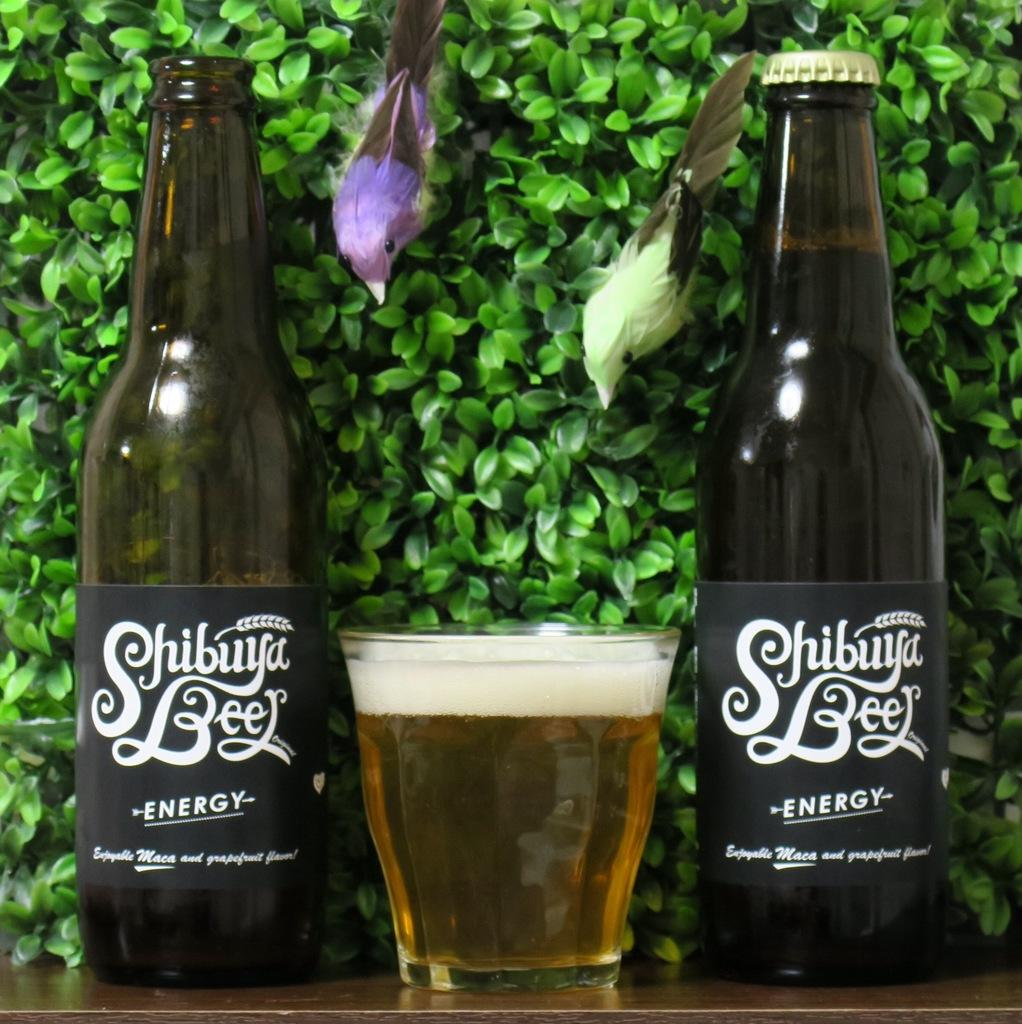<image>
Create a compact narrative representing the image presented. Two bottles of Shibuya beer sit on either side of a glass of beer. 